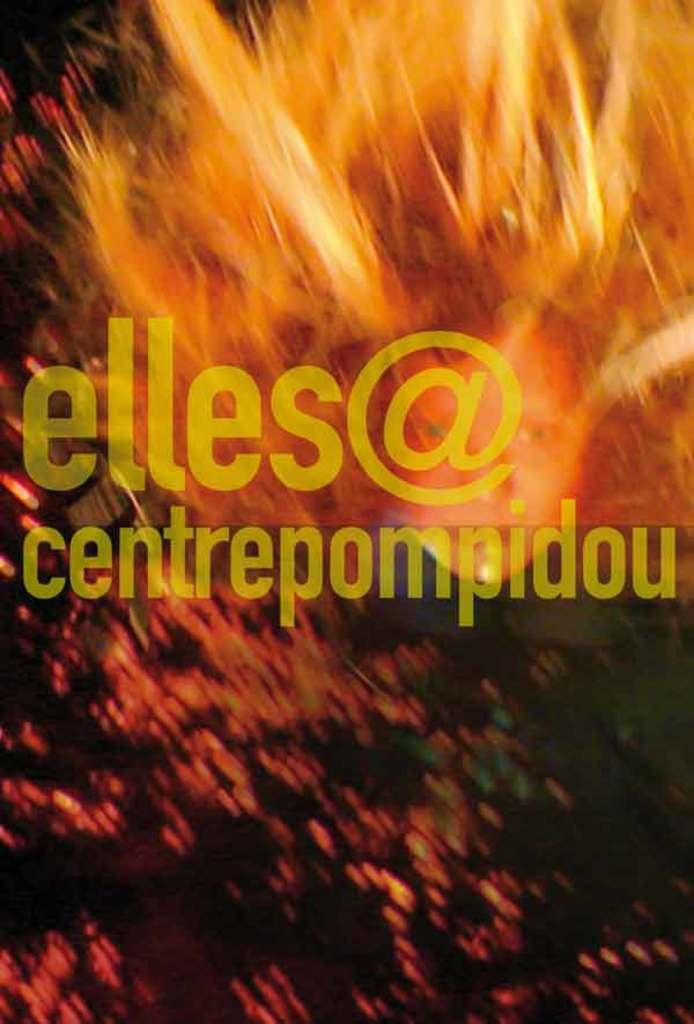<image>
Offer a succinct explanation of the picture presented. A fiery yellow background shows the text elles@centrepompiduo. 